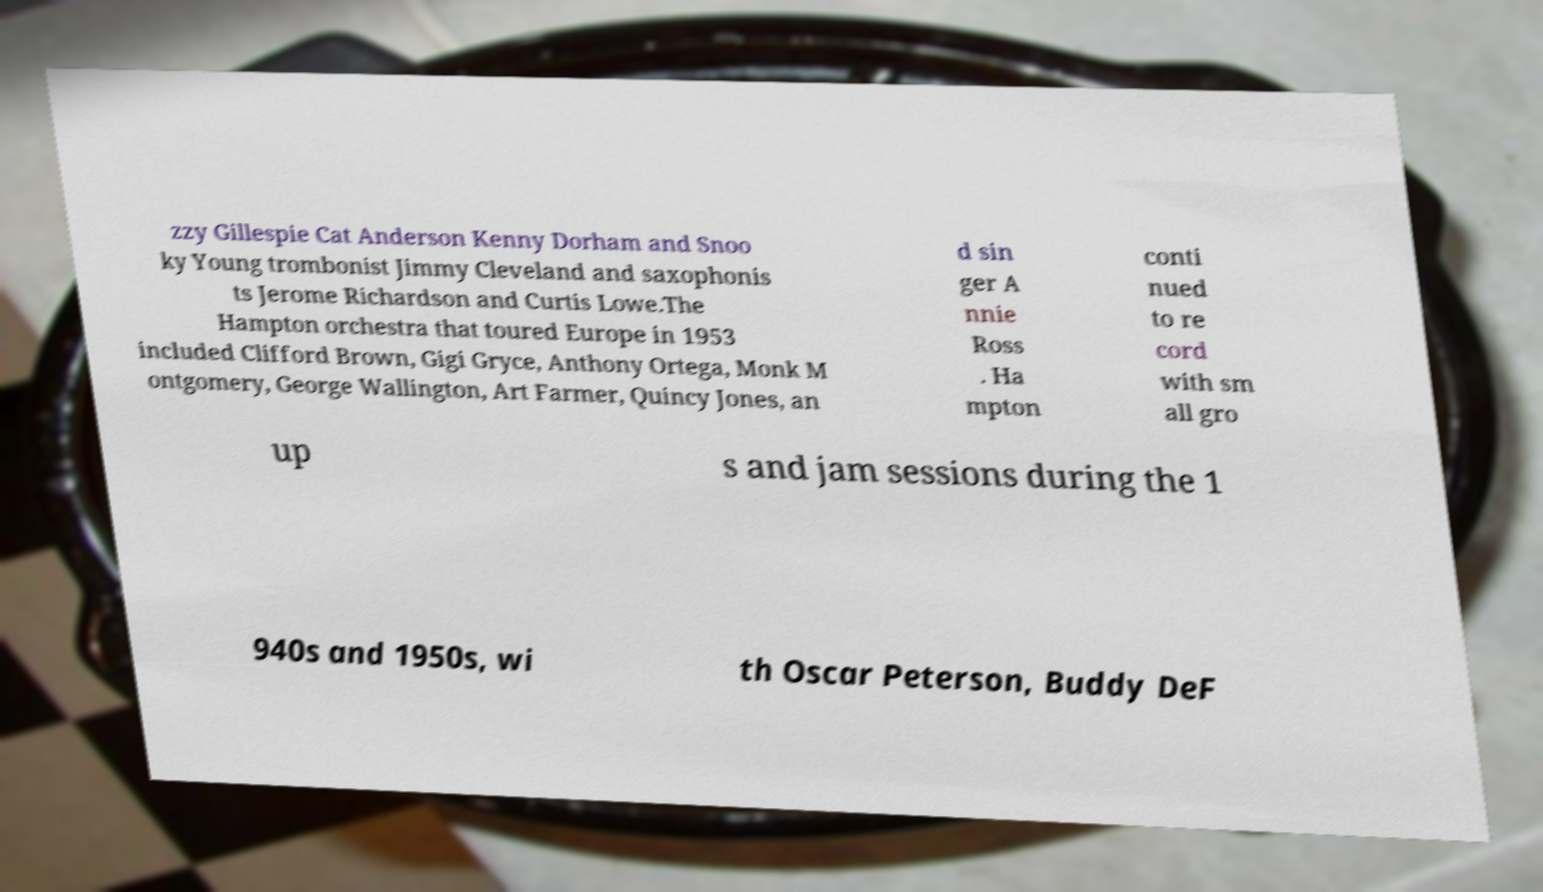There's text embedded in this image that I need extracted. Can you transcribe it verbatim? zzy Gillespie Cat Anderson Kenny Dorham and Snoo ky Young trombonist Jimmy Cleveland and saxophonis ts Jerome Richardson and Curtis Lowe.The Hampton orchestra that toured Europe in 1953 included Clifford Brown, Gigi Gryce, Anthony Ortega, Monk M ontgomery, George Wallington, Art Farmer, Quincy Jones, an d sin ger A nnie Ross . Ha mpton conti nued to re cord with sm all gro up s and jam sessions during the 1 940s and 1950s, wi th Oscar Peterson, Buddy DeF 